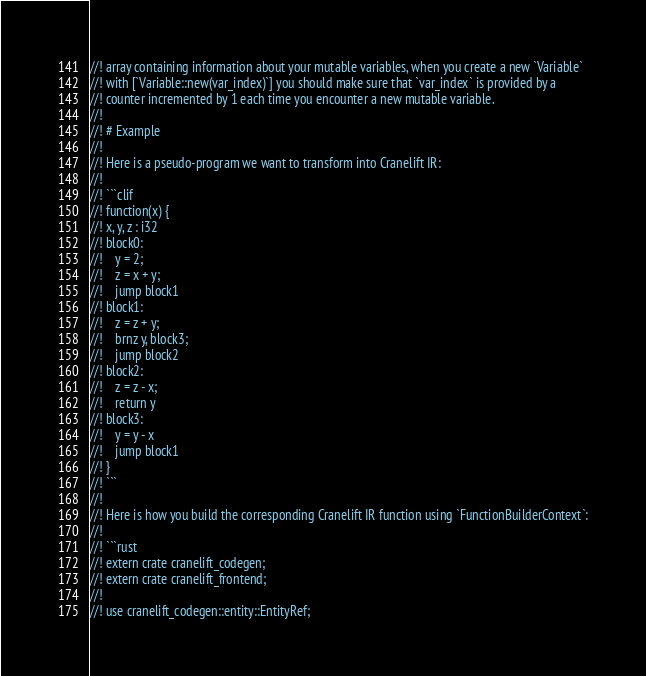Convert code to text. <code><loc_0><loc_0><loc_500><loc_500><_Rust_>//! array containing information about your mutable variables, when you create a new `Variable`
//! with [`Variable::new(var_index)`] you should make sure that `var_index` is provided by a
//! counter incremented by 1 each time you encounter a new mutable variable.
//!
//! # Example
//!
//! Here is a pseudo-program we want to transform into Cranelift IR:
//!
//! ```clif
//! function(x) {
//! x, y, z : i32
//! block0:
//!    y = 2;
//!    z = x + y;
//!    jump block1
//! block1:
//!    z = z + y;
//!    brnz y, block3;
//!    jump block2
//! block2:
//!    z = z - x;
//!    return y
//! block3:
//!    y = y - x
//!    jump block1
//! }
//! ```
//!
//! Here is how you build the corresponding Cranelift IR function using `FunctionBuilderContext`:
//!
//! ```rust
//! extern crate cranelift_codegen;
//! extern crate cranelift_frontend;
//!
//! use cranelift_codegen::entity::EntityRef;</code> 